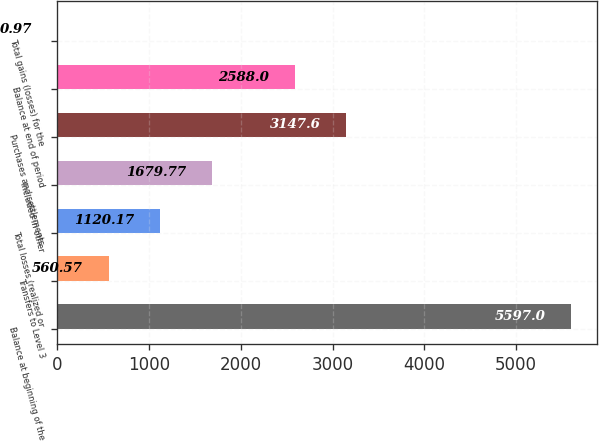Convert chart to OTSL. <chart><loc_0><loc_0><loc_500><loc_500><bar_chart><fcel>Balance at beginning of the<fcel>Transfers to Level 3<fcel>Total losses (realized or<fcel>Included in other<fcel>Purchases and settlements<fcel>Balance at end of period<fcel>Total gains (losses) for the<nl><fcel>5597<fcel>560.57<fcel>1120.17<fcel>1679.77<fcel>3147.6<fcel>2588<fcel>0.97<nl></chart> 